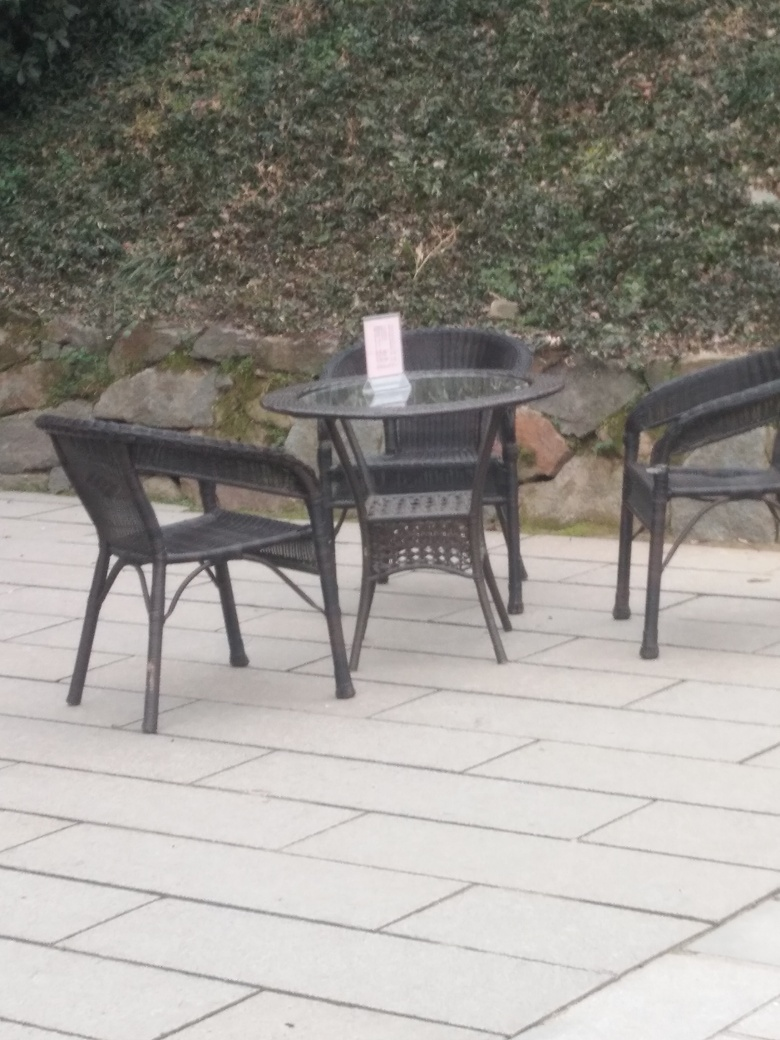Do the chair and table lack most of the texture details? While the chair and table exhibit a minimalistic design with some muted textures, they do not completely lack texture details. The design features a woven pattern, albeit with a relatively uniform and simplistic style that might not stand out at first glance. 